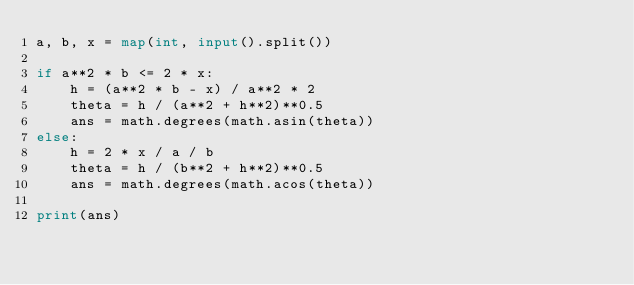Convert code to text. <code><loc_0><loc_0><loc_500><loc_500><_Python_>a, b, x = map(int, input().split())

if a**2 * b <= 2 * x:
    h = (a**2 * b - x) / a**2 * 2
    theta = h / (a**2 + h**2)**0.5
    ans = math.degrees(math.asin(theta))
else:
    h = 2 * x / a / b
    theta = h / (b**2 + h**2)**0.5
    ans = math.degrees(math.acos(theta))

print(ans)</code> 